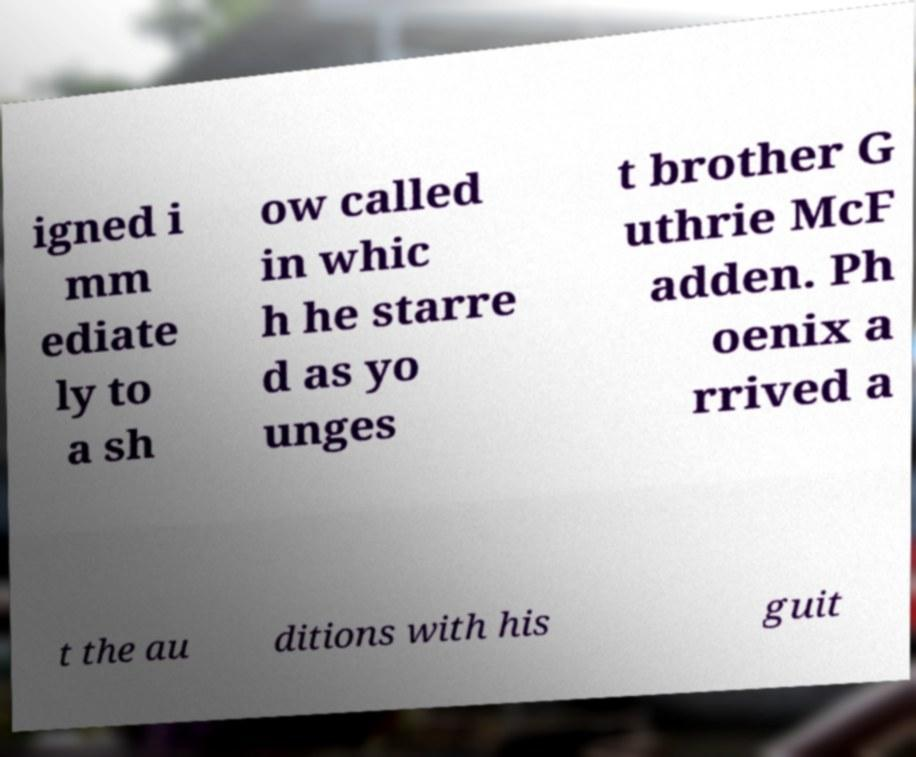Please read and relay the text visible in this image. What does it say? igned i mm ediate ly to a sh ow called in whic h he starre d as yo unges t brother G uthrie McF adden. Ph oenix a rrived a t the au ditions with his guit 